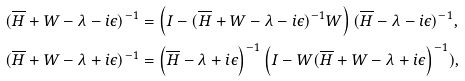Convert formula to latex. <formula><loc_0><loc_0><loc_500><loc_500>( \overline { H } + W - \lambda - i \epsilon ) ^ { - 1 } & = \left ( I - ( \overline { H } + W - \lambda - i \epsilon ) ^ { - 1 } W \right ) ( \overline { H } - \lambda - i \epsilon ) ^ { - 1 } , \\ ( \overline { H } + W - \lambda + i \epsilon ) ^ { - 1 } & = \left ( \overline { H } - \lambda + i \epsilon \right ) ^ { - 1 } \left ( I - W ( \overline { H } + W - \lambda + i \epsilon \right ) ^ { - 1 } ) ,</formula> 